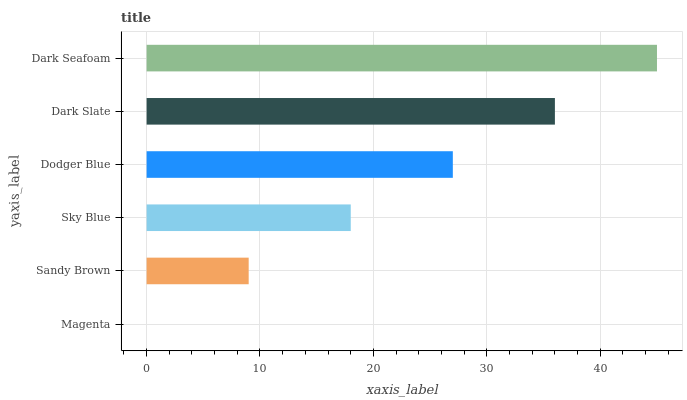Is Magenta the minimum?
Answer yes or no. Yes. Is Dark Seafoam the maximum?
Answer yes or no. Yes. Is Sandy Brown the minimum?
Answer yes or no. No. Is Sandy Brown the maximum?
Answer yes or no. No. Is Sandy Brown greater than Magenta?
Answer yes or no. Yes. Is Magenta less than Sandy Brown?
Answer yes or no. Yes. Is Magenta greater than Sandy Brown?
Answer yes or no. No. Is Sandy Brown less than Magenta?
Answer yes or no. No. Is Dodger Blue the high median?
Answer yes or no. Yes. Is Sky Blue the low median?
Answer yes or no. Yes. Is Dark Seafoam the high median?
Answer yes or no. No. Is Dark Slate the low median?
Answer yes or no. No. 